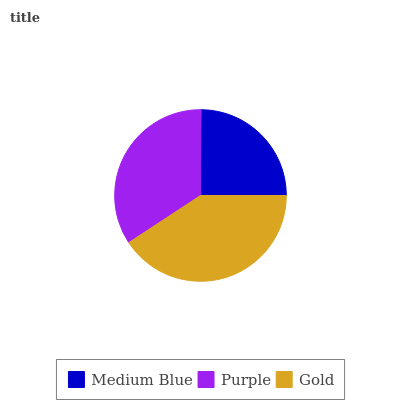Is Medium Blue the minimum?
Answer yes or no. Yes. Is Gold the maximum?
Answer yes or no. Yes. Is Purple the minimum?
Answer yes or no. No. Is Purple the maximum?
Answer yes or no. No. Is Purple greater than Medium Blue?
Answer yes or no. Yes. Is Medium Blue less than Purple?
Answer yes or no. Yes. Is Medium Blue greater than Purple?
Answer yes or no. No. Is Purple less than Medium Blue?
Answer yes or no. No. Is Purple the high median?
Answer yes or no. Yes. Is Purple the low median?
Answer yes or no. Yes. Is Gold the high median?
Answer yes or no. No. Is Medium Blue the low median?
Answer yes or no. No. 